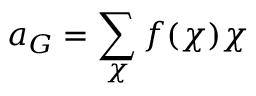Convert formula to latex. <formula><loc_0><loc_0><loc_500><loc_500>a _ { G } = \sum _ { \chi } f ( \chi ) \chi</formula> 